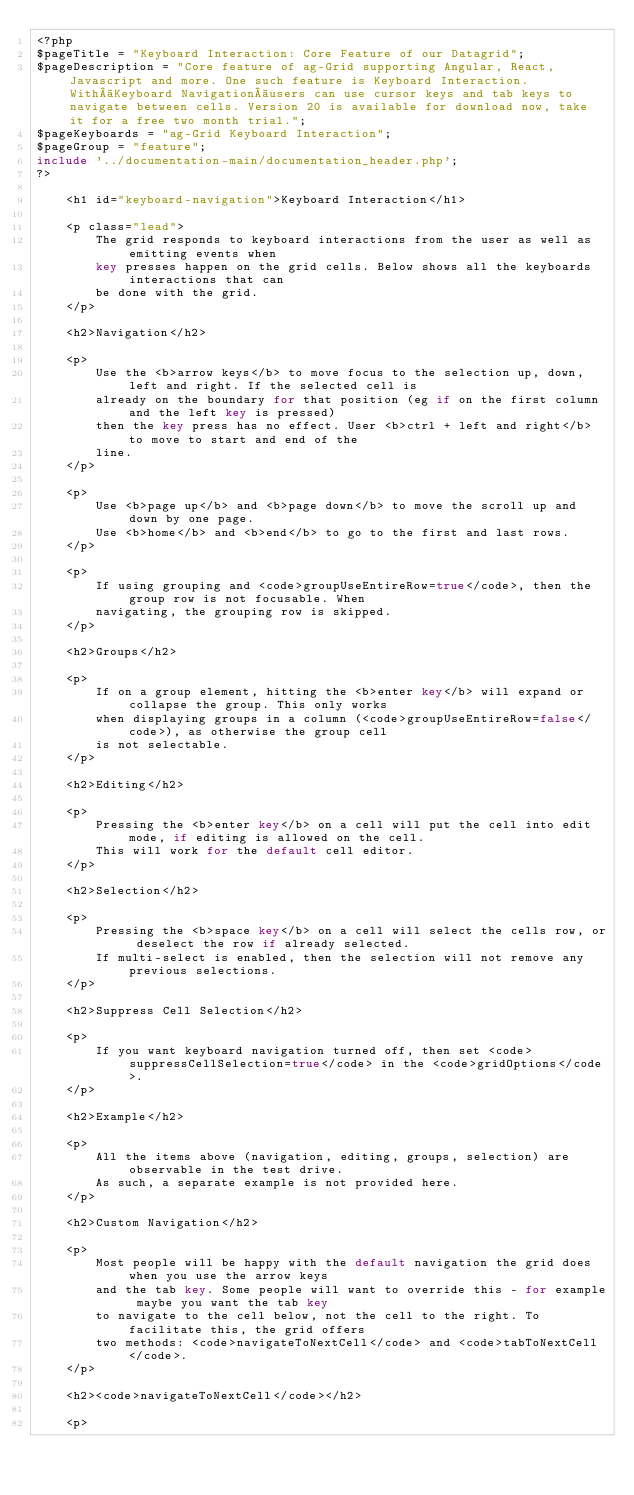<code> <loc_0><loc_0><loc_500><loc_500><_PHP_><?php
$pageTitle = "Keyboard Interaction: Core Feature of our Datagrid";
$pageDescription = "Core feature of ag-Grid supporting Angular, React, Javascript and more. One such feature is Keyboard Interaction. With Keyboard Navigation users can use cursor keys and tab keys to navigate between cells. Version 20 is available for download now, take it for a free two month trial.";
$pageKeyboards = "ag-Grid Keyboard Interaction";
$pageGroup = "feature";
include '../documentation-main/documentation_header.php';
?>

    <h1 id="keyboard-navigation">Keyboard Interaction</h1>

    <p class="lead">
        The grid responds to keyboard interactions from the user as well as emitting events when
        key presses happen on the grid cells. Below shows all the keyboards interactions that can
        be done with the grid.
    </p>

    <h2>Navigation</h2>

    <p>
        Use the <b>arrow keys</b> to move focus to the selection up, down, left and right. If the selected cell is
        already on the boundary for that position (eg if on the first column and the left key is pressed)
        then the key press has no effect. User <b>ctrl + left and right</b> to move to start and end of the
        line.
    </p>

    <p>
        Use <b>page up</b> and <b>page down</b> to move the scroll up and down by one page.
        Use <b>home</b> and <b>end</b> to go to the first and last rows.
    </p>

    <p>
        If using grouping and <code>groupUseEntireRow=true</code>, then the group row is not focusable. When
        navigating, the grouping row is skipped.
    </p>

    <h2>Groups</h2>

    <p>
        If on a group element, hitting the <b>enter key</b> will expand or collapse the group. This only works
        when displaying groups in a column (<code>groupUseEntireRow=false</code>), as otherwise the group cell
        is not selectable.
    </p>

    <h2>Editing</h2>

    <p>
        Pressing the <b>enter key</b> on a cell will put the cell into edit mode, if editing is allowed on the cell.
        This will work for the default cell editor.
    </p>

    <h2>Selection</h2>

    <p>
        Pressing the <b>space key</b> on a cell will select the cells row, or deselect the row if already selected.
        If multi-select is enabled, then the selection will not remove any previous selections.
    </p>

    <h2>Suppress Cell Selection</h2>

    <p>
        If you want keyboard navigation turned off, then set <code>suppressCellSelection=true</code> in the <code>gridOptions</code>.
    </p>

    <h2>Example</h2>

    <p>
        All the items above (navigation, editing, groups, selection) are observable in the test drive.
        As such, a separate example is not provided here.
    </p>

    <h2>Custom Navigation</h2>

    <p>
        Most people will be happy with the default navigation the grid does when you use the arrow keys
        and the tab key. Some people will want to override this - for example maybe you want the tab key
        to navigate to the cell below, not the cell to the right. To facilitate this, the grid offers
        two methods: <code>navigateToNextCell</code> and <code>tabToNextCell</code>.
    </p>

    <h2><code>navigateToNextCell</code></h2>

    <p></code> 